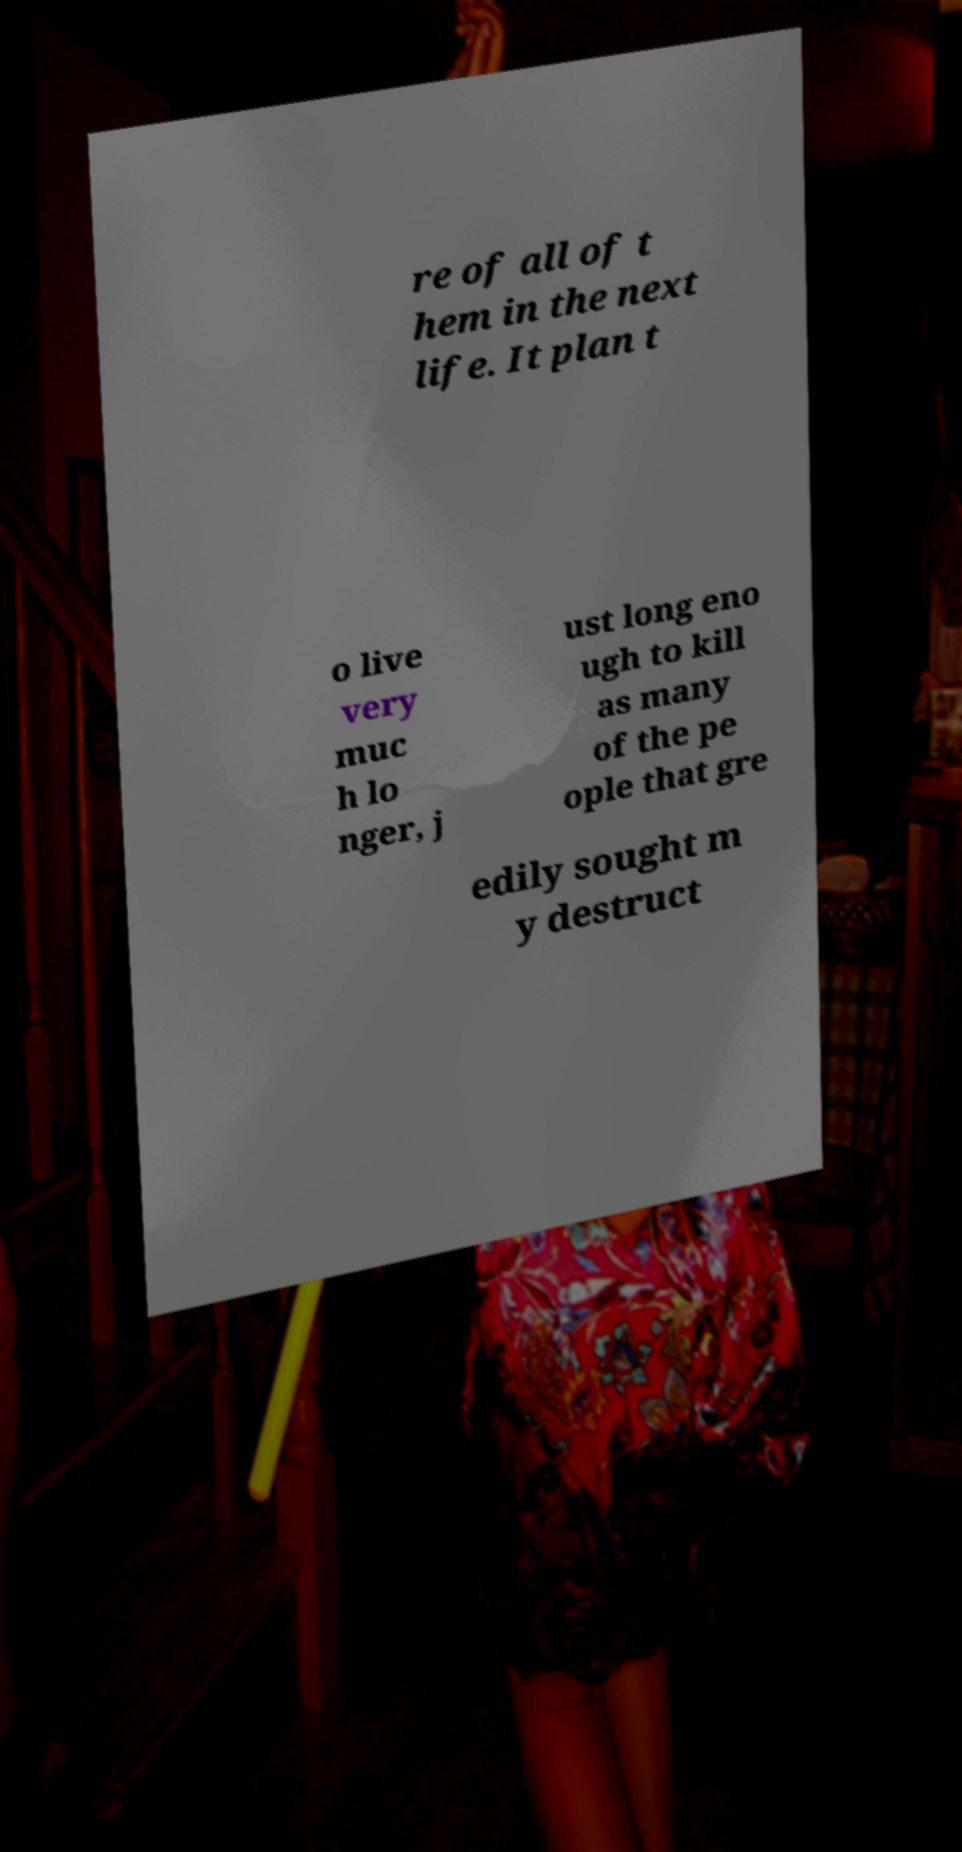Can you read and provide the text displayed in the image?This photo seems to have some interesting text. Can you extract and type it out for me? re of all of t hem in the next life. It plan t o live very muc h lo nger, j ust long eno ugh to kill as many of the pe ople that gre edily sought m y destruct 